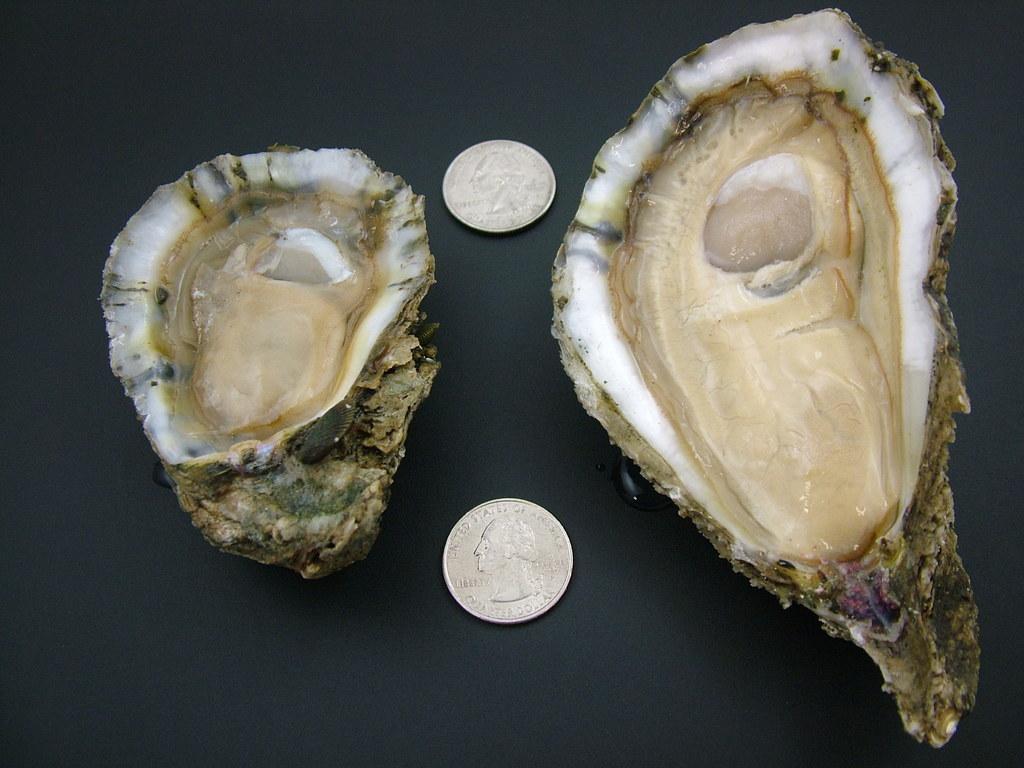Can you describe this image briefly? In the center of the image we can see shells and two coins with some images and some text. And we can see the dark background. 